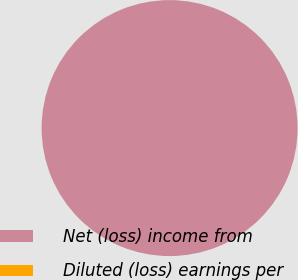<chart> <loc_0><loc_0><loc_500><loc_500><pie_chart><fcel>Net (loss) income from<fcel>Diluted (loss) earnings per<nl><fcel>100.0%<fcel>0.0%<nl></chart> 